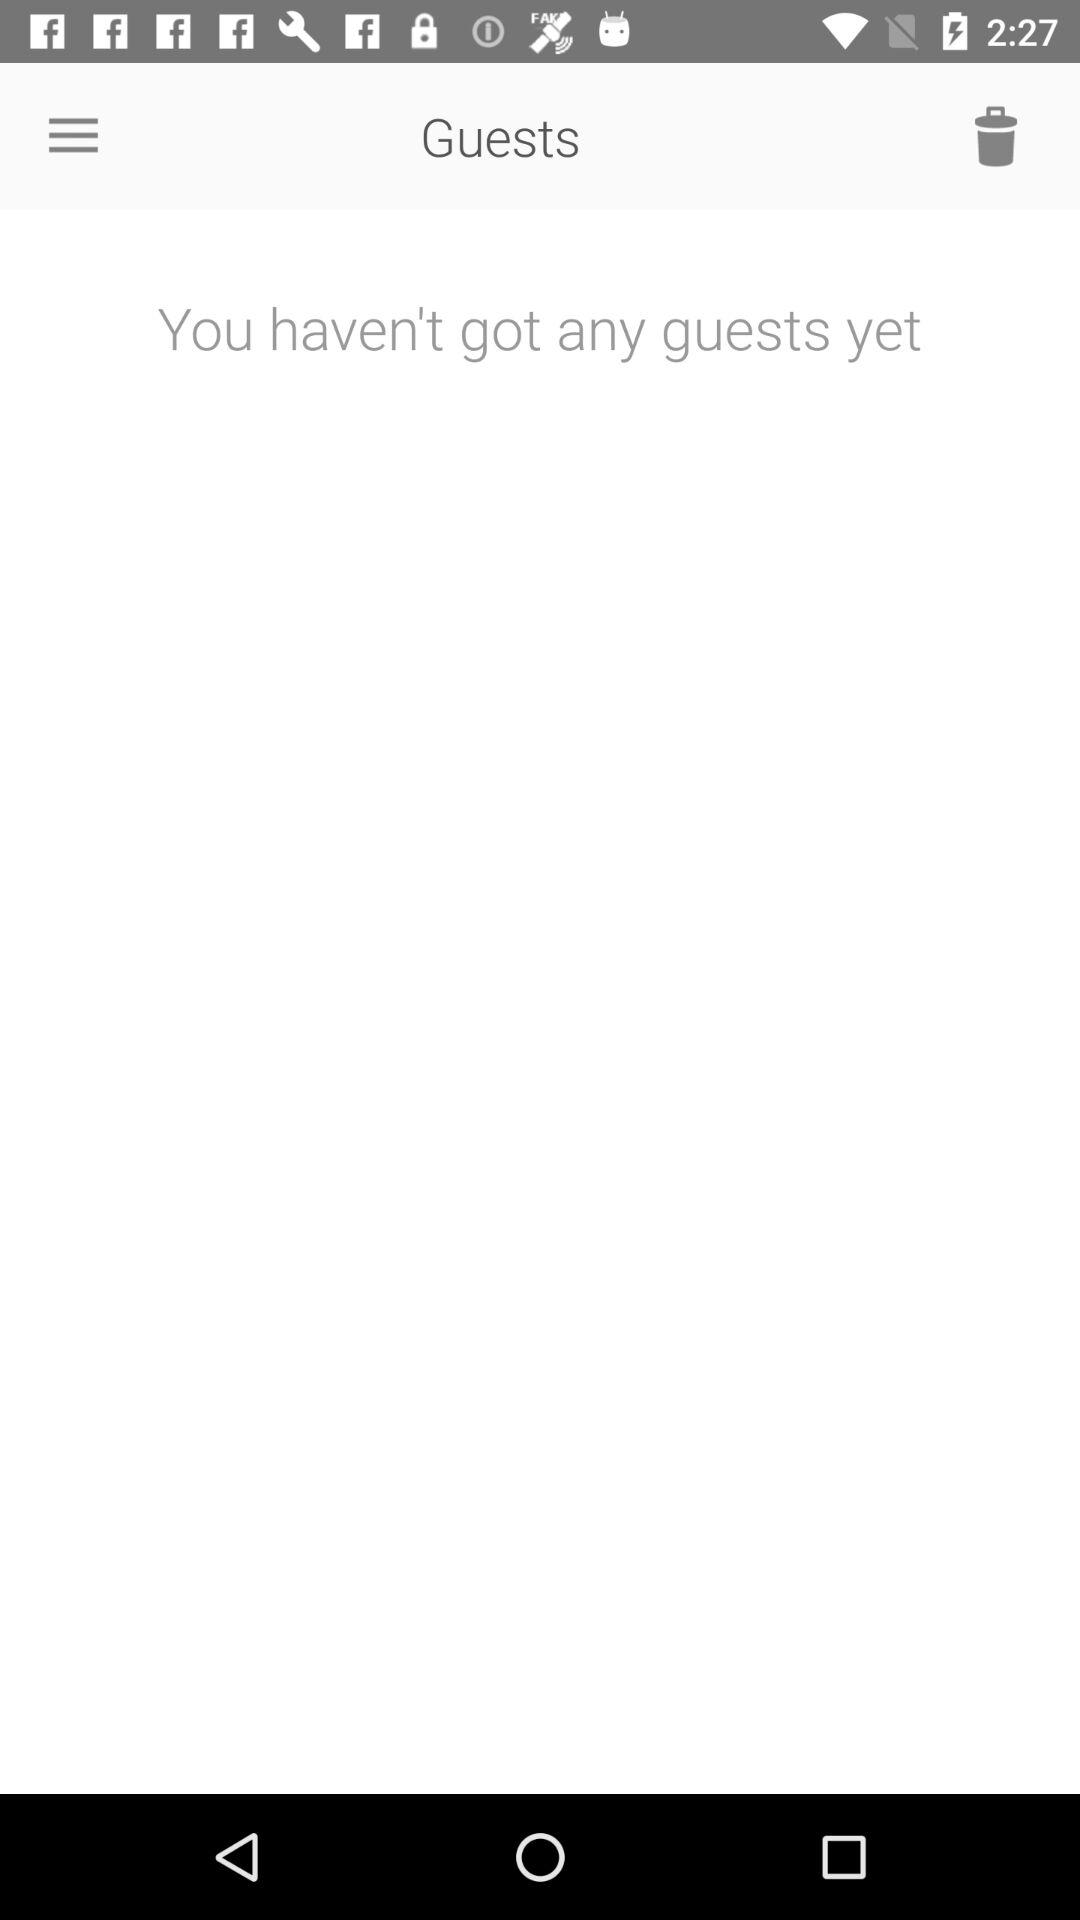Are there any guests? There are no guests. 